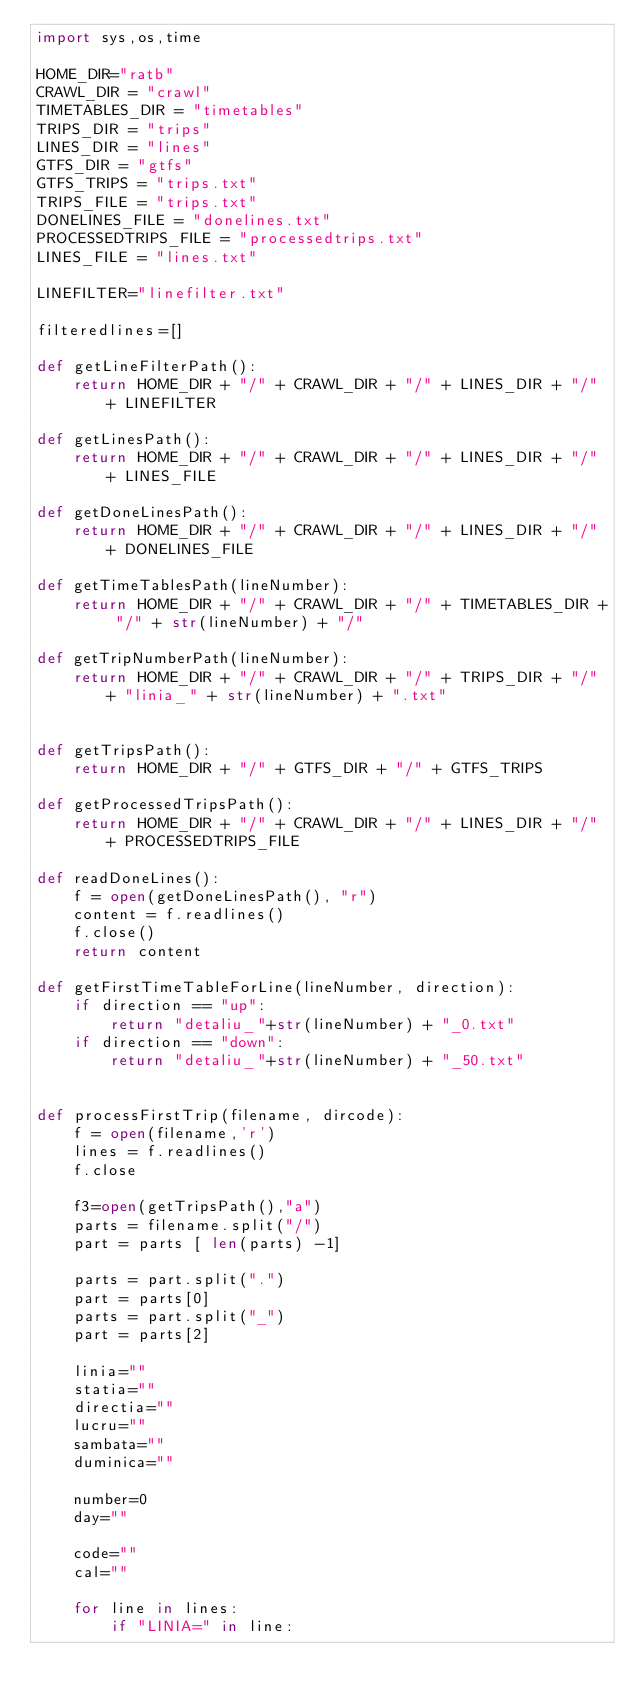<code> <loc_0><loc_0><loc_500><loc_500><_Python_>import sys,os,time

HOME_DIR="ratb"
CRAWL_DIR = "crawl"
TIMETABLES_DIR = "timetables"
TRIPS_DIR = "trips"
LINES_DIR = "lines"
GTFS_DIR = "gtfs"
GTFS_TRIPS = "trips.txt"
TRIPS_FILE = "trips.txt"
DONELINES_FILE = "donelines.txt"
PROCESSEDTRIPS_FILE = "processedtrips.txt"
LINES_FILE = "lines.txt"

LINEFILTER="linefilter.txt"

filteredlines=[]

def getLineFilterPath():
    return HOME_DIR + "/" + CRAWL_DIR + "/" + LINES_DIR + "/" + LINEFILTER

def getLinesPath():
    return HOME_DIR + "/" + CRAWL_DIR + "/" + LINES_DIR + "/" + LINES_FILE

def getDoneLinesPath():
    return HOME_DIR + "/" + CRAWL_DIR + "/" + LINES_DIR + "/" + DONELINES_FILE

def getTimeTablesPath(lineNumber):
    return HOME_DIR + "/" + CRAWL_DIR + "/" + TIMETABLES_DIR + "/" + str(lineNumber) + "/"

def getTripNumberPath(lineNumber):
    return HOME_DIR + "/" + CRAWL_DIR + "/" + TRIPS_DIR + "/" + "linia_" + str(lineNumber) + ".txt"


def getTripsPath():
    return HOME_DIR + "/" + GTFS_DIR + "/" + GTFS_TRIPS

def getProcessedTripsPath():
    return HOME_DIR + "/" + CRAWL_DIR + "/" + LINES_DIR + "/" + PROCESSEDTRIPS_FILE

def readDoneLines():
    f = open(getDoneLinesPath(), "r")
    content = f.readlines()
    f.close()
    return content

def getFirstTimeTableForLine(lineNumber, direction):
    if direction == "up":
        return "detaliu_"+str(lineNumber) + "_0.txt"
    if direction == "down":
        return "detaliu_"+str(lineNumber) + "_50.txt"


def processFirstTrip(filename, dircode):
    f = open(filename,'r')
    lines = f.readlines()
    f.close
    
    f3=open(getTripsPath(),"a") 
    parts = filename.split("/")
    part = parts [ len(parts) -1]

    parts = part.split(".")
    part = parts[0]
    parts = part.split("_")
    part = parts[2]
 
    linia=""
    statia=""
    directia=""
    lucru=""
    sambata=""
    duminica=""
   
    number=0
    day=""   
       
    code="" 
    cal=""

    for line in lines:
        if "LINIA=" in line:</code> 